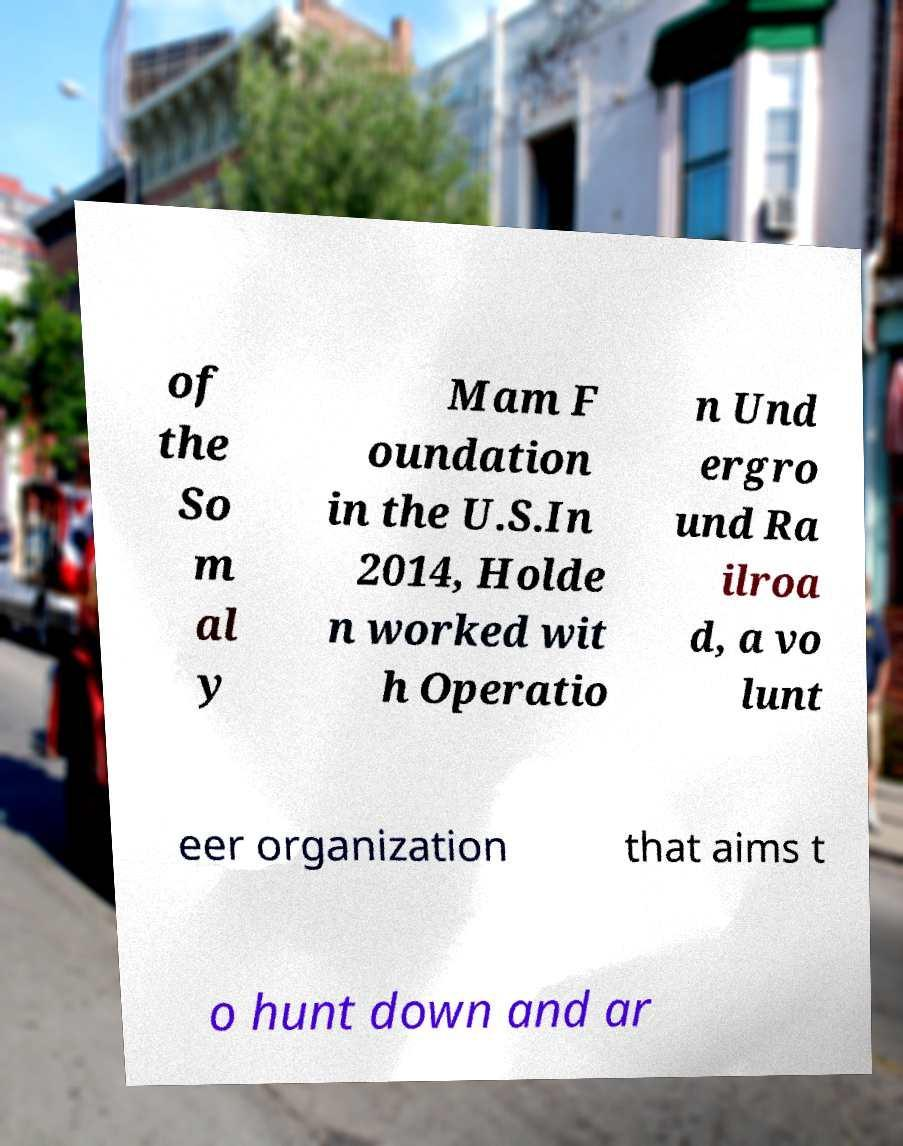There's text embedded in this image that I need extracted. Can you transcribe it verbatim? of the So m al y Mam F oundation in the U.S.In 2014, Holde n worked wit h Operatio n Und ergro und Ra ilroa d, a vo lunt eer organization that aims t o hunt down and ar 